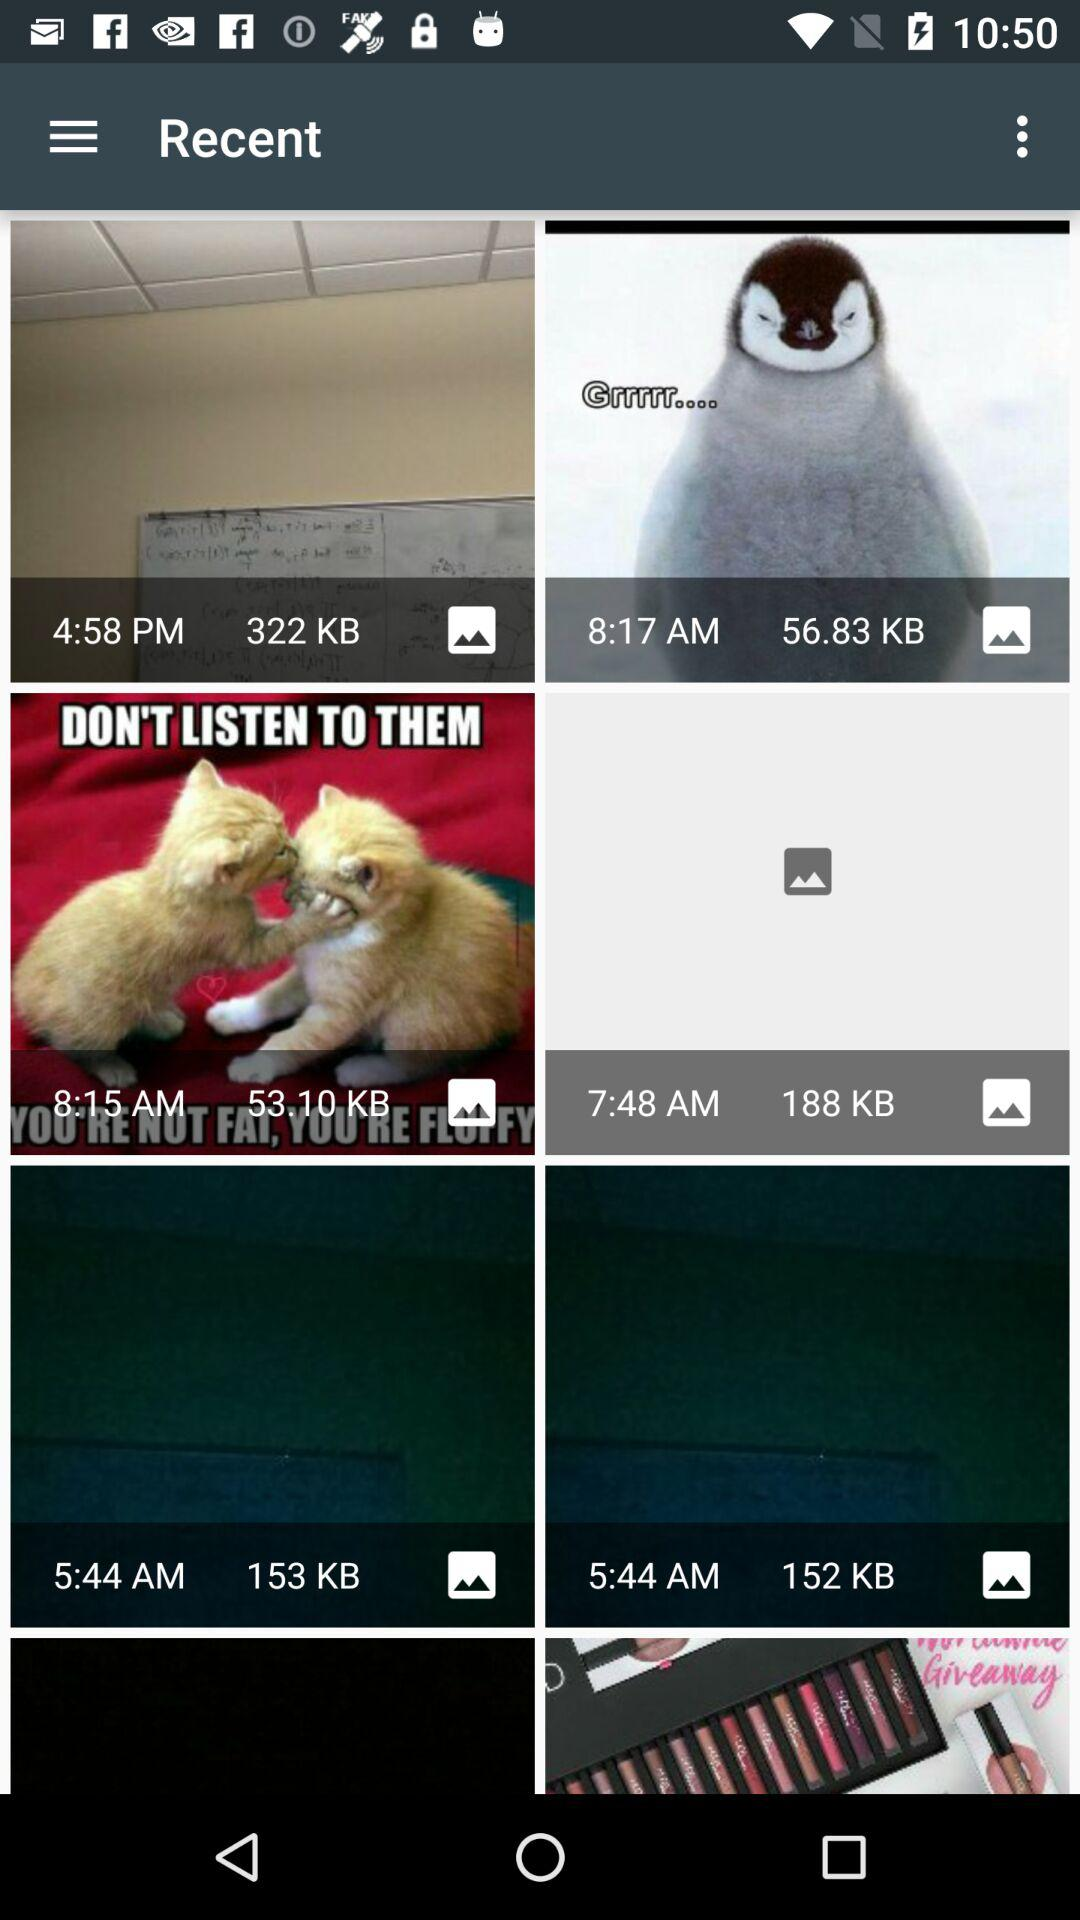How many KB of files are there in the first file? There are 322 KB in the first file. 